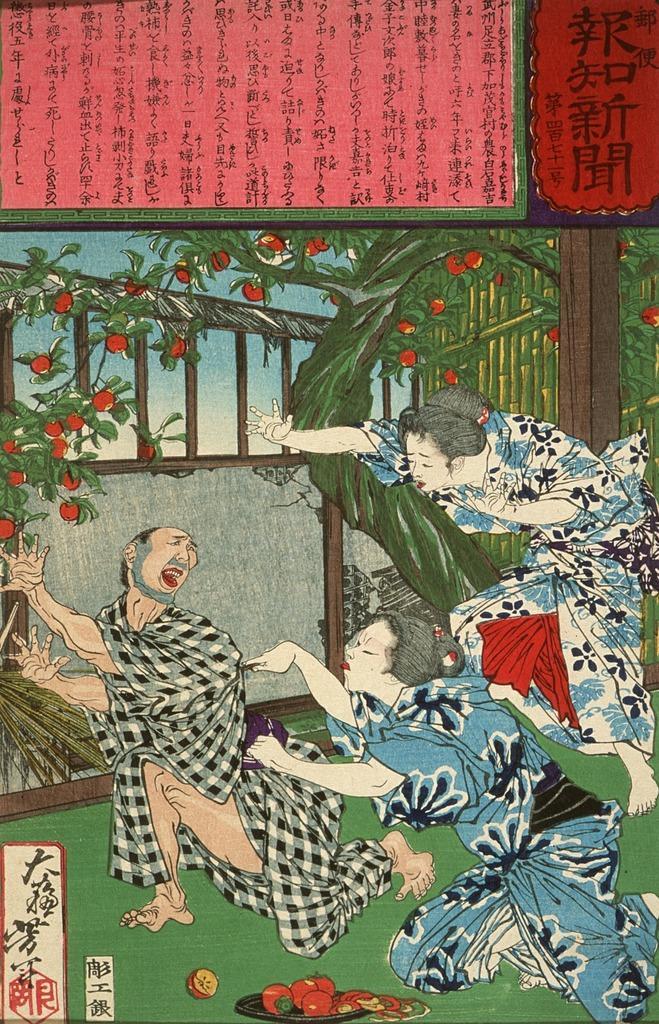Could you give a brief overview of what you see in this image? In this picture there is a poster in the center of the image. 